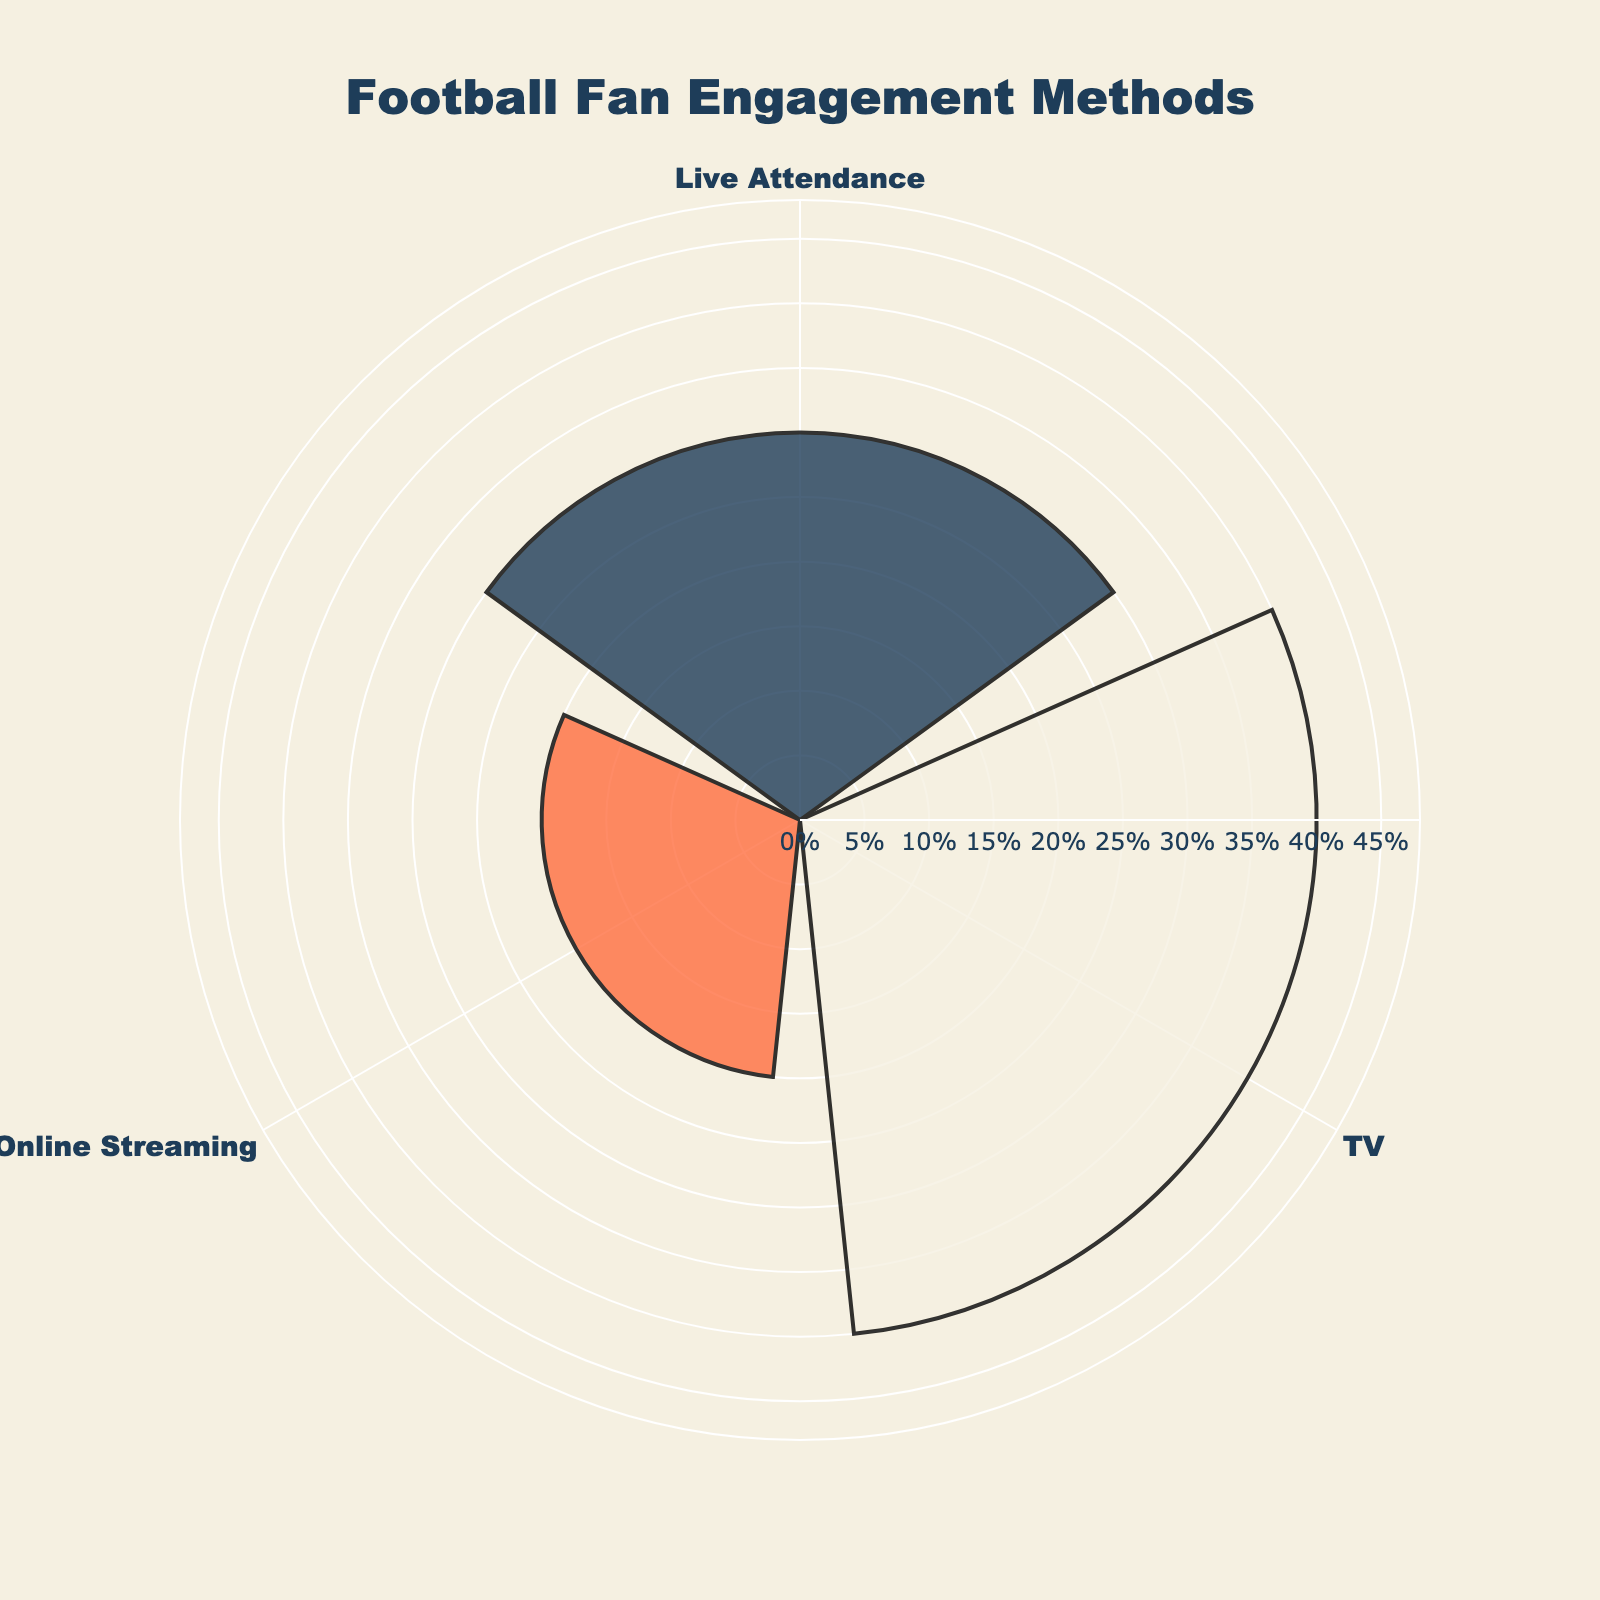What is the title of the rose chart? The title is located at the top center of the chart. The text is "Football Fan Engagement Methods."
Answer: Football Fan Engagement Methods What is the engagement method with the highest percentage? By looking at the radial lengths, TV has the longest bar at 40%.
Answer: TV What are the percentages for Live Attendance and Online Streaming combined? Adding the percentages of Live Attendance (30%) and Online Streaming (20%), we get 30% + 20% = 50%.
Answer: 50% Which engagement method is the least popular among the given options? The shortest bar is for Online Streaming, which has 20%.
Answer: Online Streaming Compare the popularity of Live Attendance and TV Watching. Which one is more popular and by how much? TV Watching has a percentage of 40%, and Live Attendance has 30%. The difference is 40% - 30% = 10%.
Answer: TV Watching is more popular by 10% How many groups are represented in the rose chart? There are three bars, one for each engagement method: Live Attendance, TV, and Online Streaming.
Answer: 3 What is the average percentage of the three engagement methods shown? The sum of the percentages for Live Attendance (30%), TV (40%), and Online Streaming (20%) is 30% + 40% + 20% = 90%. The average is 90% / 3 = 30%.
Answer: 30% If Social Media Interactions were included, how many total groups would there be? Initially, Social Media Interactions were excluded. Including it would bring the total to 4 groups.
Answer: 4 Is the polar axis visible in the rose chart? The axis marks are visible, which can be confirmed by the presence of the percentages labeled around the chart.
Answer: Yes 